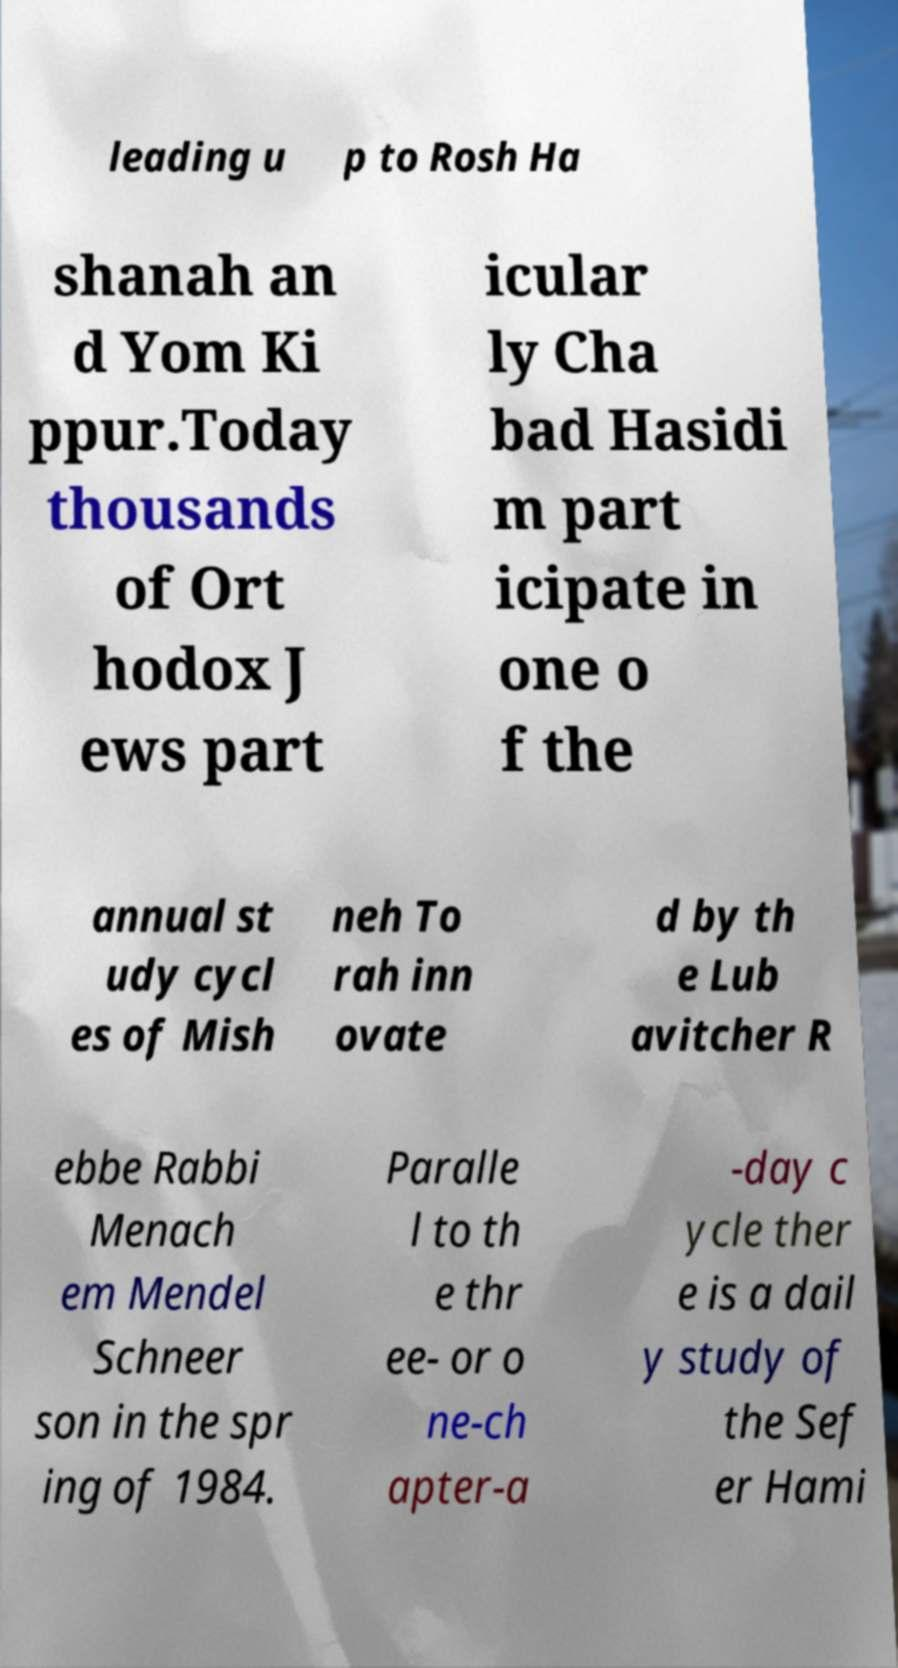Can you read and provide the text displayed in the image?This photo seems to have some interesting text. Can you extract and type it out for me? leading u p to Rosh Ha shanah an d Yom Ki ppur.Today thousands of Ort hodox J ews part icular ly Cha bad Hasidi m part icipate in one o f the annual st udy cycl es of Mish neh To rah inn ovate d by th e Lub avitcher R ebbe Rabbi Menach em Mendel Schneer son in the spr ing of 1984. Paralle l to th e thr ee- or o ne-ch apter-a -day c ycle ther e is a dail y study of the Sef er Hami 